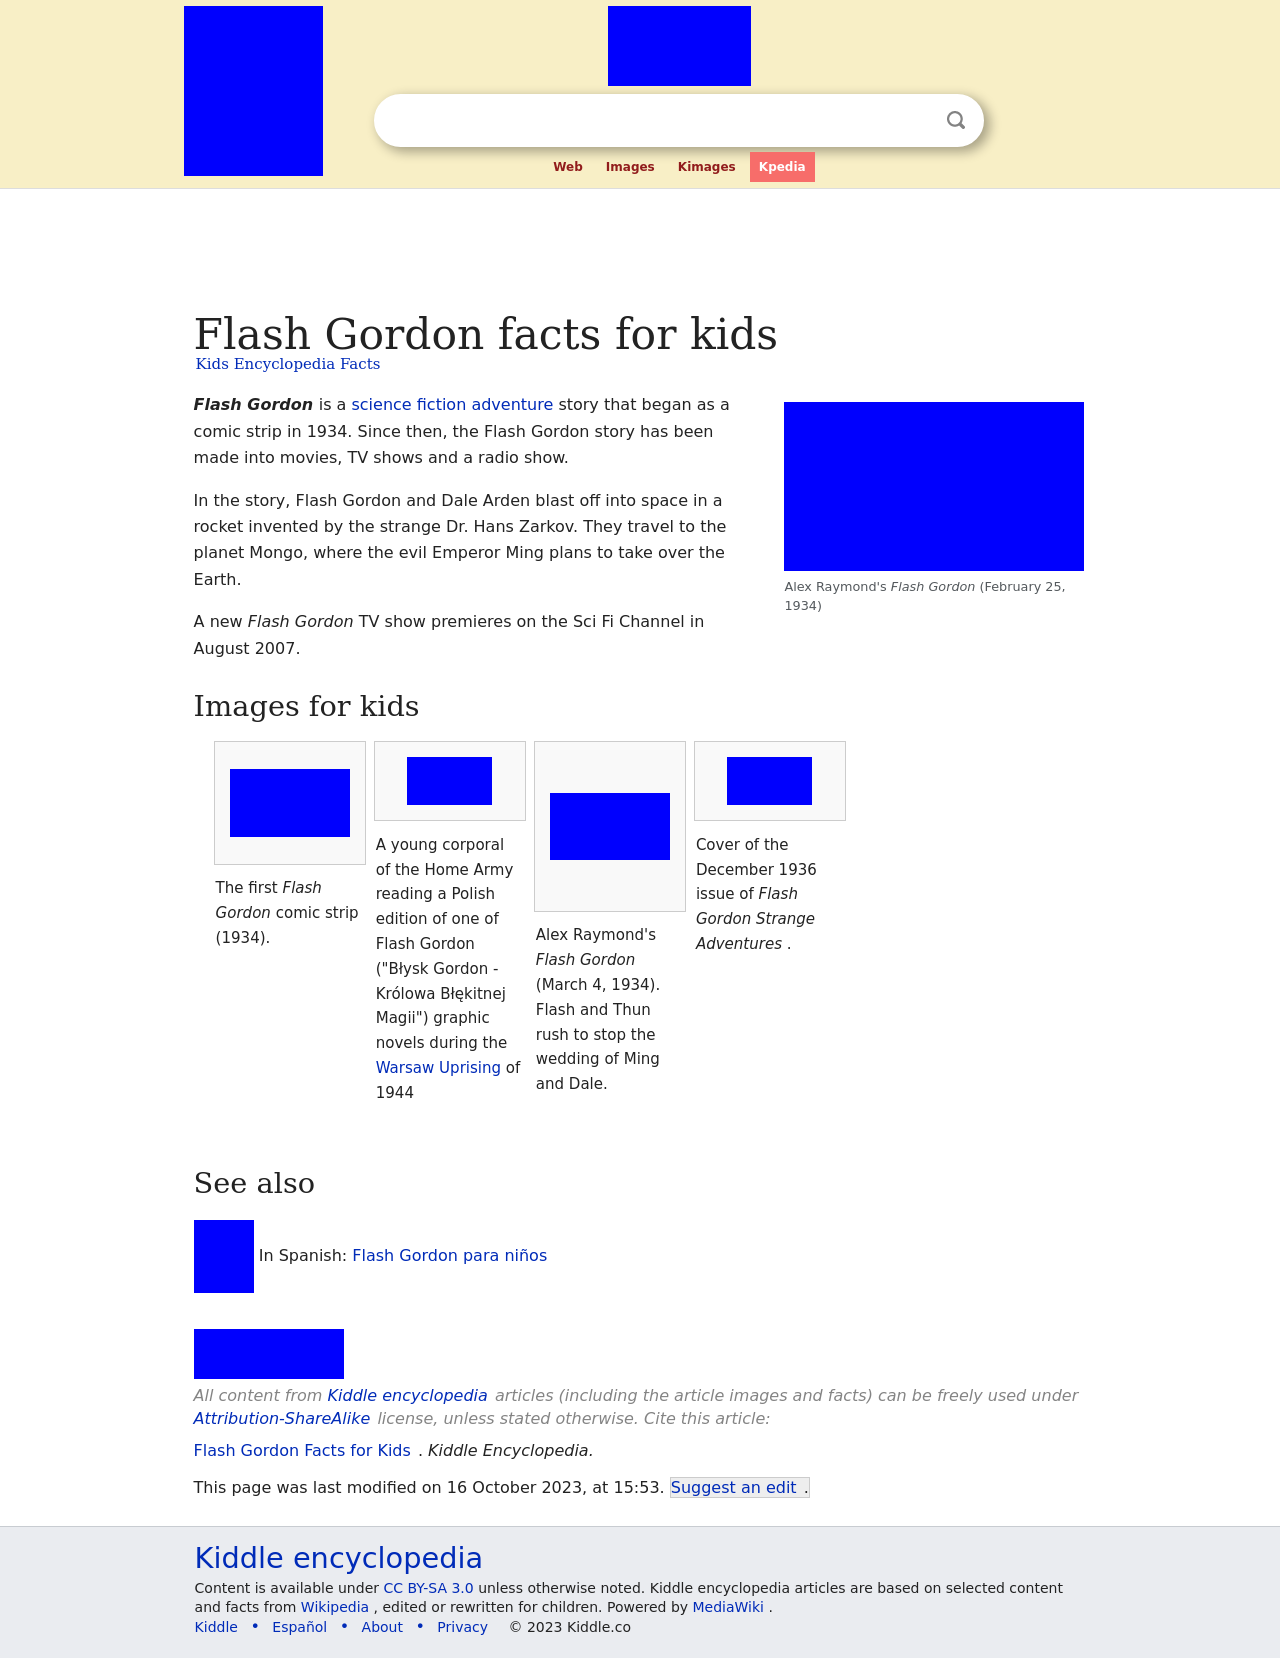Can you tell me more about the creation of the first Flash Gordon comic strip in 1934? The first Flash Gordon comic strip debuted on January 7, 1934. It was created by Alex Raymond to compete with the already popular Buck Rogers adventure strip. The comic quickly gained acclaim for its exceptional artwork and exotic adventure stories that transported readers to new, thrilling worlds. 